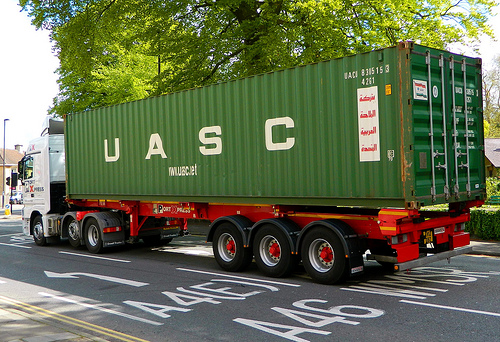Describe the type of environment and surroundings visible in the image? The image shows a street scene with a large green cargo container on a truck. There are trees indicating it's an outdoor setting, and road markings are visible on the asphalt. What do you think the significance of the container's color might be? The green color of the container might be to align with corporate colors or to blend in with nature, perhaps to signify ecological responsibility or brand identity. 